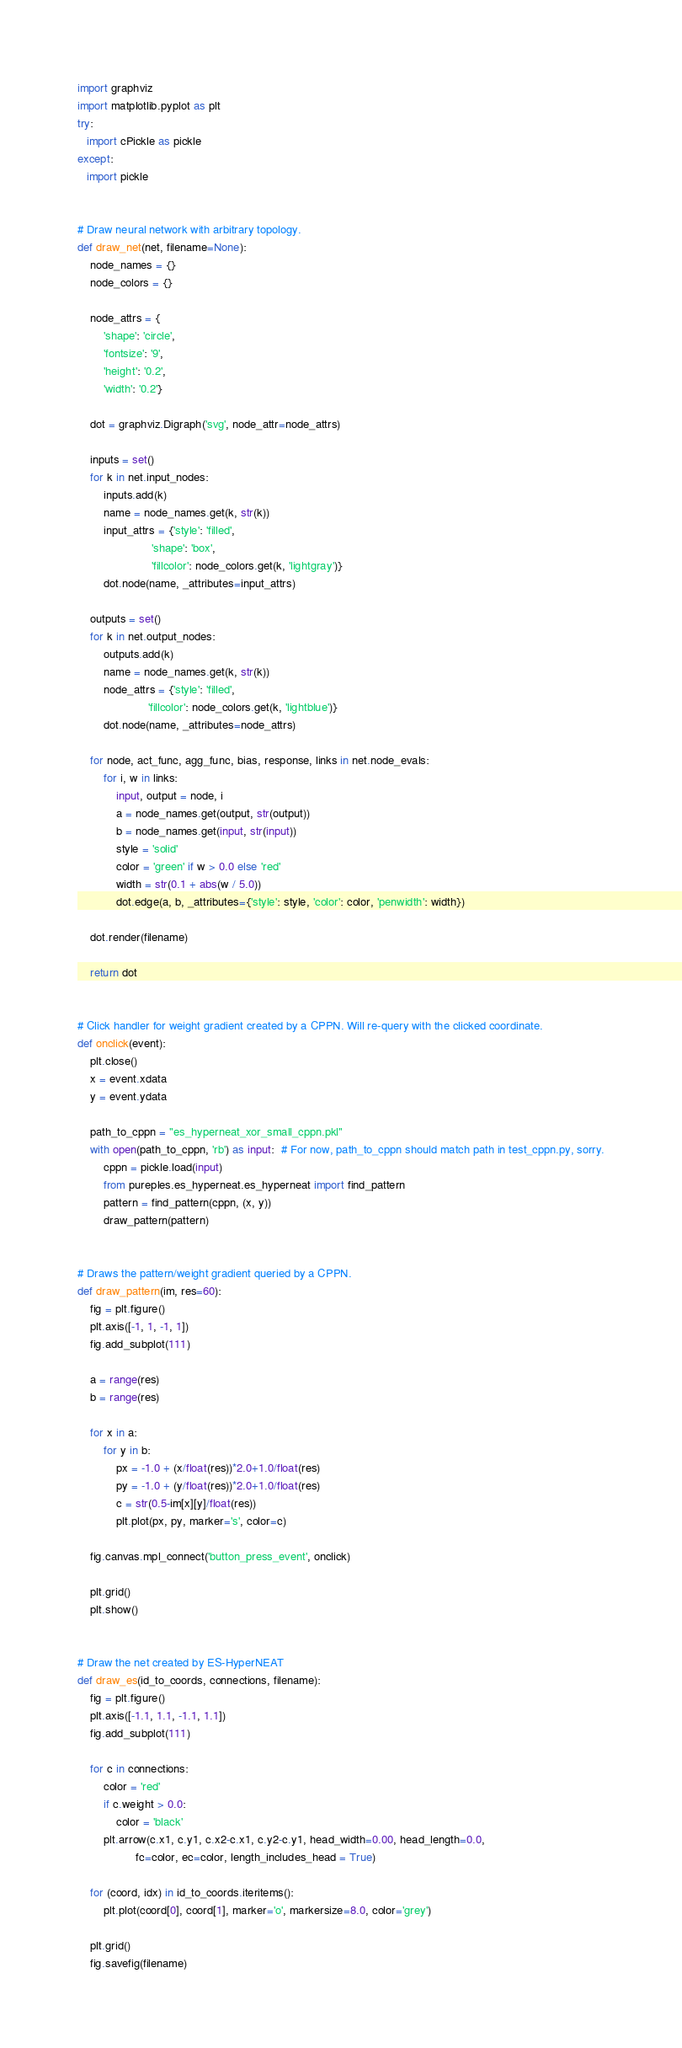Convert code to text. <code><loc_0><loc_0><loc_500><loc_500><_Python_>import graphviz 
import matplotlib.pyplot as plt
try:
   import cPickle as pickle
except:
   import pickle


# Draw neural network with arbitrary topology.
def draw_net(net, filename=None):
    node_names = {}
    node_colors = {}

    node_attrs = {
        'shape': 'circle',
        'fontsize': '9',
        'height': '0.2',
        'width': '0.2'}

    dot = graphviz.Digraph('svg', node_attr=node_attrs)

    inputs = set()
    for k in net.input_nodes:
        inputs.add(k)
        name = node_names.get(k, str(k))
        input_attrs = {'style': 'filled', 
                       'shape': 'box', 
                       'fillcolor': node_colors.get(k, 'lightgray')}
        dot.node(name, _attributes=input_attrs)

    outputs = set()
    for k in net.output_nodes:
        outputs.add(k)
        name = node_names.get(k, str(k))
        node_attrs = {'style': 'filled', 
                      'fillcolor': node_colors.get(k, 'lightblue')}
        dot.node(name, _attributes=node_attrs)

    for node, act_func, agg_func, bias, response, links in net.node_evals:
        for i, w in links:
            input, output = node, i
            a = node_names.get(output, str(output))
            b = node_names.get(input, str(input))
            style = 'solid'
            color = 'green' if w > 0.0 else 'red'
            width = str(0.1 + abs(w / 5.0))
            dot.edge(a, b, _attributes={'style': style, 'color': color, 'penwidth': width})

    dot.render(filename)

    return dot


# Click handler for weight gradient created by a CPPN. Will re-query with the clicked coordinate.
def onclick(event):
    plt.close()
    x = event.xdata
    y = event.ydata
    
    path_to_cppn = "es_hyperneat_xor_small_cppn.pkl"
    with open(path_to_cppn, 'rb') as input:  # For now, path_to_cppn should match path in test_cppn.py, sorry.
        cppn = pickle.load(input)
        from pureples.es_hyperneat.es_hyperneat import find_pattern
        pattern = find_pattern(cppn, (x, y))
        draw_pattern(pattern)


# Draws the pattern/weight gradient queried by a CPPN. 
def draw_pattern(im, res=60):
    fig = plt.figure()
    plt.axis([-1, 1, -1, 1])
    fig.add_subplot(111)

    a = range(res)
    b = range(res)

    for x in a:
        for y in b:
            px = -1.0 + (x/float(res))*2.0+1.0/float(res)
            py = -1.0 + (y/float(res))*2.0+1.0/float(res)
            c = str(0.5-im[x][y]/float(res))
            plt.plot(px, py, marker='s', color=c)

    fig.canvas.mpl_connect('button_press_event', onclick)

    plt.grid()
    plt.show()


# Draw the net created by ES-HyperNEAT
def draw_es(id_to_coords, connections, filename):
    fig = plt.figure()
    plt.axis([-1.1, 1.1, -1.1, 1.1])
    fig.add_subplot(111)

    for c in connections:
        color = 'red'
        if c.weight > 0.0:
            color = 'black'
        plt.arrow(c.x1, c.y1, c.x2-c.x1, c.y2-c.y1, head_width=0.00, head_length=0.0, 
                  fc=color, ec=color, length_includes_head = True)

    for (coord, idx) in id_to_coords.iteritems():
        plt.plot(coord[0], coord[1], marker='o', markersize=8.0, color='grey')

    plt.grid()
    fig.savefig(filename)

</code> 